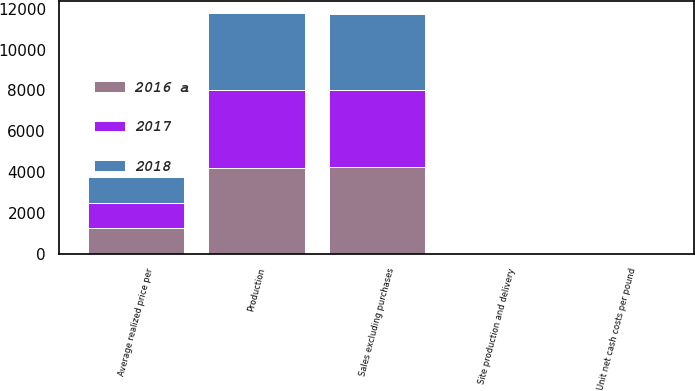<chart> <loc_0><loc_0><loc_500><loc_500><stacked_bar_chart><ecel><fcel>Production<fcel>Sales excluding purchases<fcel>Average realized price per<fcel>Site production and delivery<fcel>Unit net cash costs per pound<nl><fcel>2017<fcel>3813<fcel>3811<fcel>1254<fcel>1.76<fcel>1.07<nl><fcel>2018<fcel>3737<fcel>3700<fcel>1268<fcel>1.6<fcel>1.19<nl><fcel>2016 a<fcel>4222<fcel>4227<fcel>1238<fcel>1.42<fcel>1.26<nl></chart> 